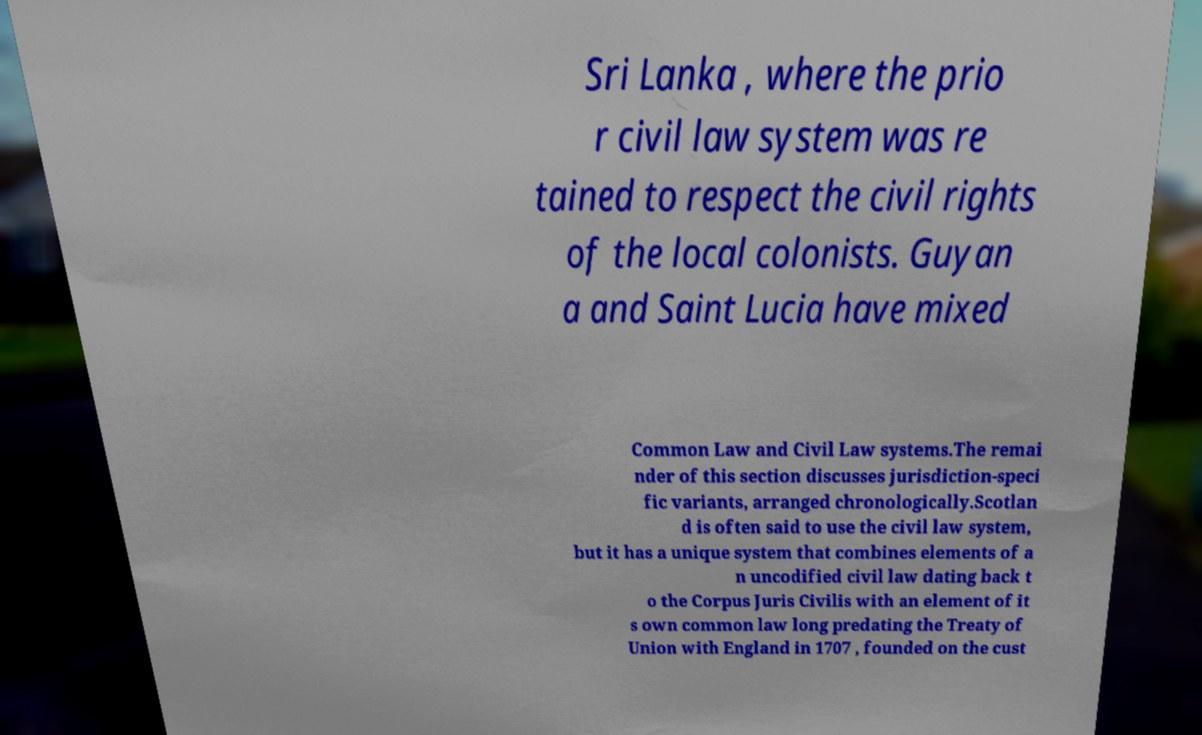Could you assist in decoding the text presented in this image and type it out clearly? Sri Lanka , where the prio r civil law system was re tained to respect the civil rights of the local colonists. Guyan a and Saint Lucia have mixed Common Law and Civil Law systems.The remai nder of this section discusses jurisdiction-speci fic variants, arranged chronologically.Scotlan d is often said to use the civil law system, but it has a unique system that combines elements of a n uncodified civil law dating back t o the Corpus Juris Civilis with an element of it s own common law long predating the Treaty of Union with England in 1707 , founded on the cust 